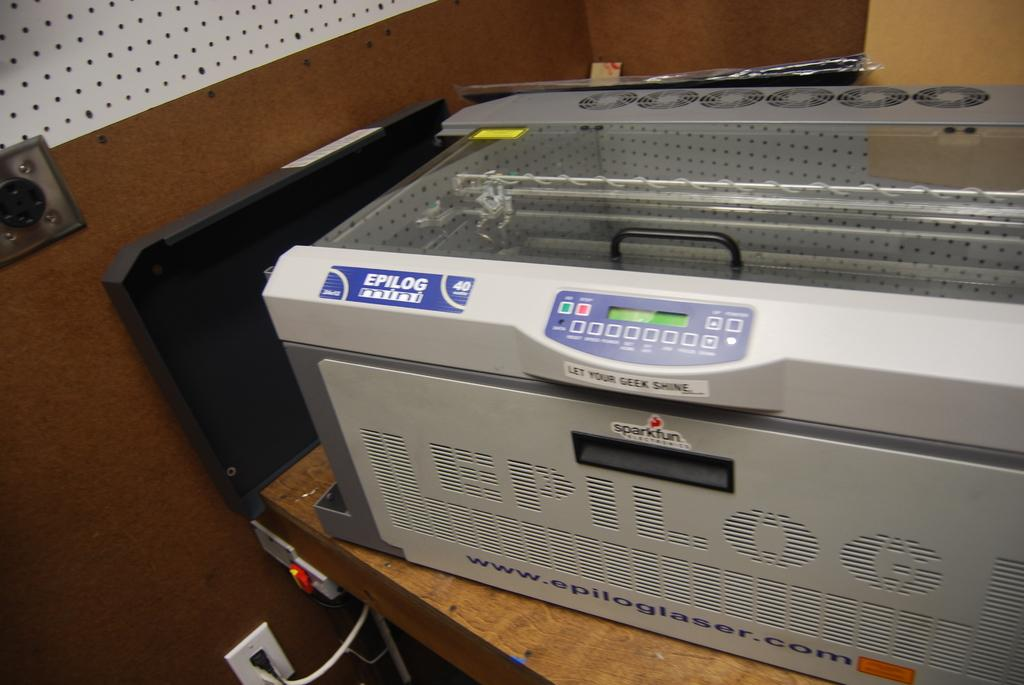Provide a one-sentence caption for the provided image. Printer with a blue label on it that says Epilog. 